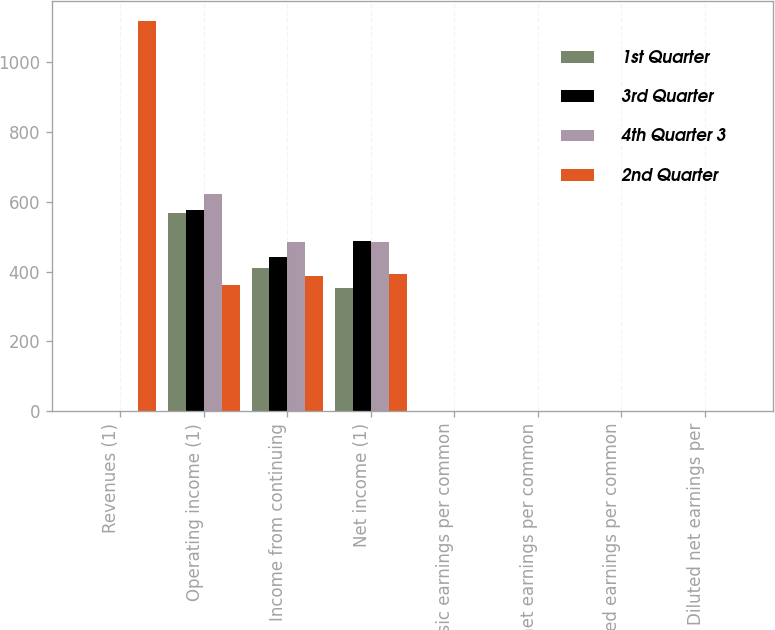Convert chart to OTSL. <chart><loc_0><loc_0><loc_500><loc_500><stacked_bar_chart><ecel><fcel>Revenues (1)<fcel>Operating income (1)<fcel>Income from continuing<fcel>Net income (1)<fcel>Basic earnings per common<fcel>Basic net earnings per common<fcel>Diluted earnings per common<fcel>Diluted net earnings per<nl><fcel>1st Quarter<fcel>0.3<fcel>568<fcel>411<fcel>352<fcel>0.26<fcel>0.22<fcel>0.25<fcel>0.21<nl><fcel>3rd Quarter<fcel>0.3<fcel>577<fcel>441<fcel>488<fcel>0.27<fcel>0.3<fcel>0.26<fcel>0.29<nl><fcel>4th Quarter 3<fcel>0.3<fcel>622<fcel>486<fcel>486<fcel>0.3<fcel>0.3<fcel>0.29<fcel>0.29<nl><fcel>2nd Quarter<fcel>1118<fcel>362<fcel>387<fcel>393<fcel>0.24<fcel>0.24<fcel>0.23<fcel>0.23<nl></chart> 